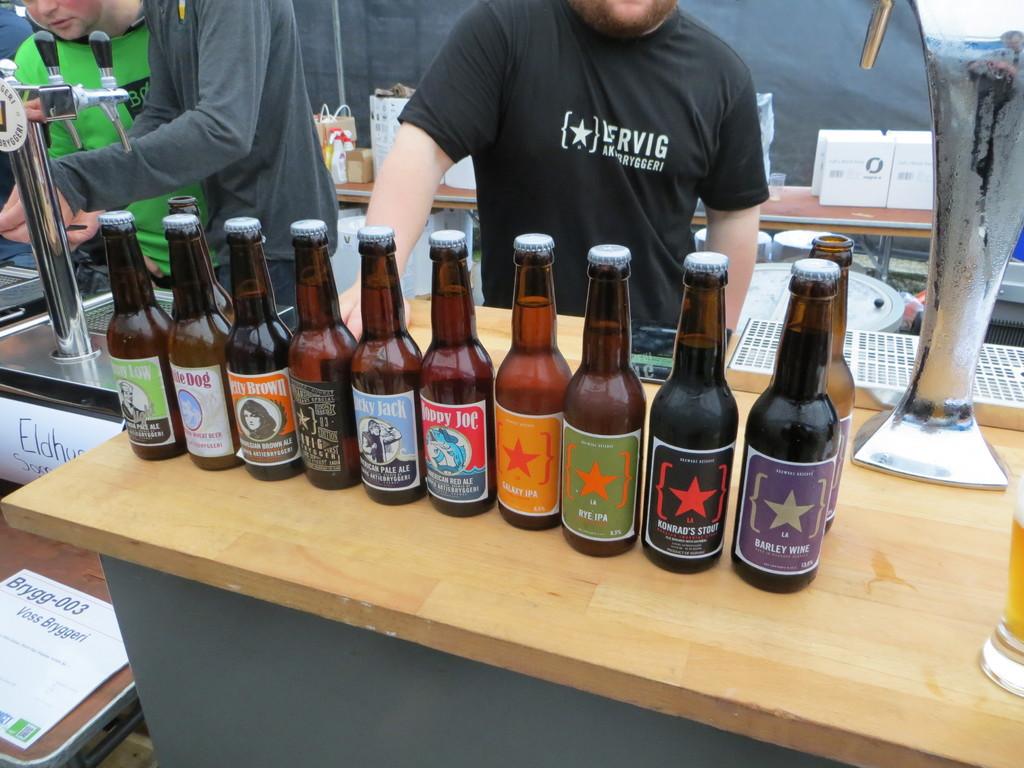What is in the bottles?
Ensure brevity in your answer.  Unanswerable. Is the barley wine on the right or the left?
Provide a succinct answer. Right. 